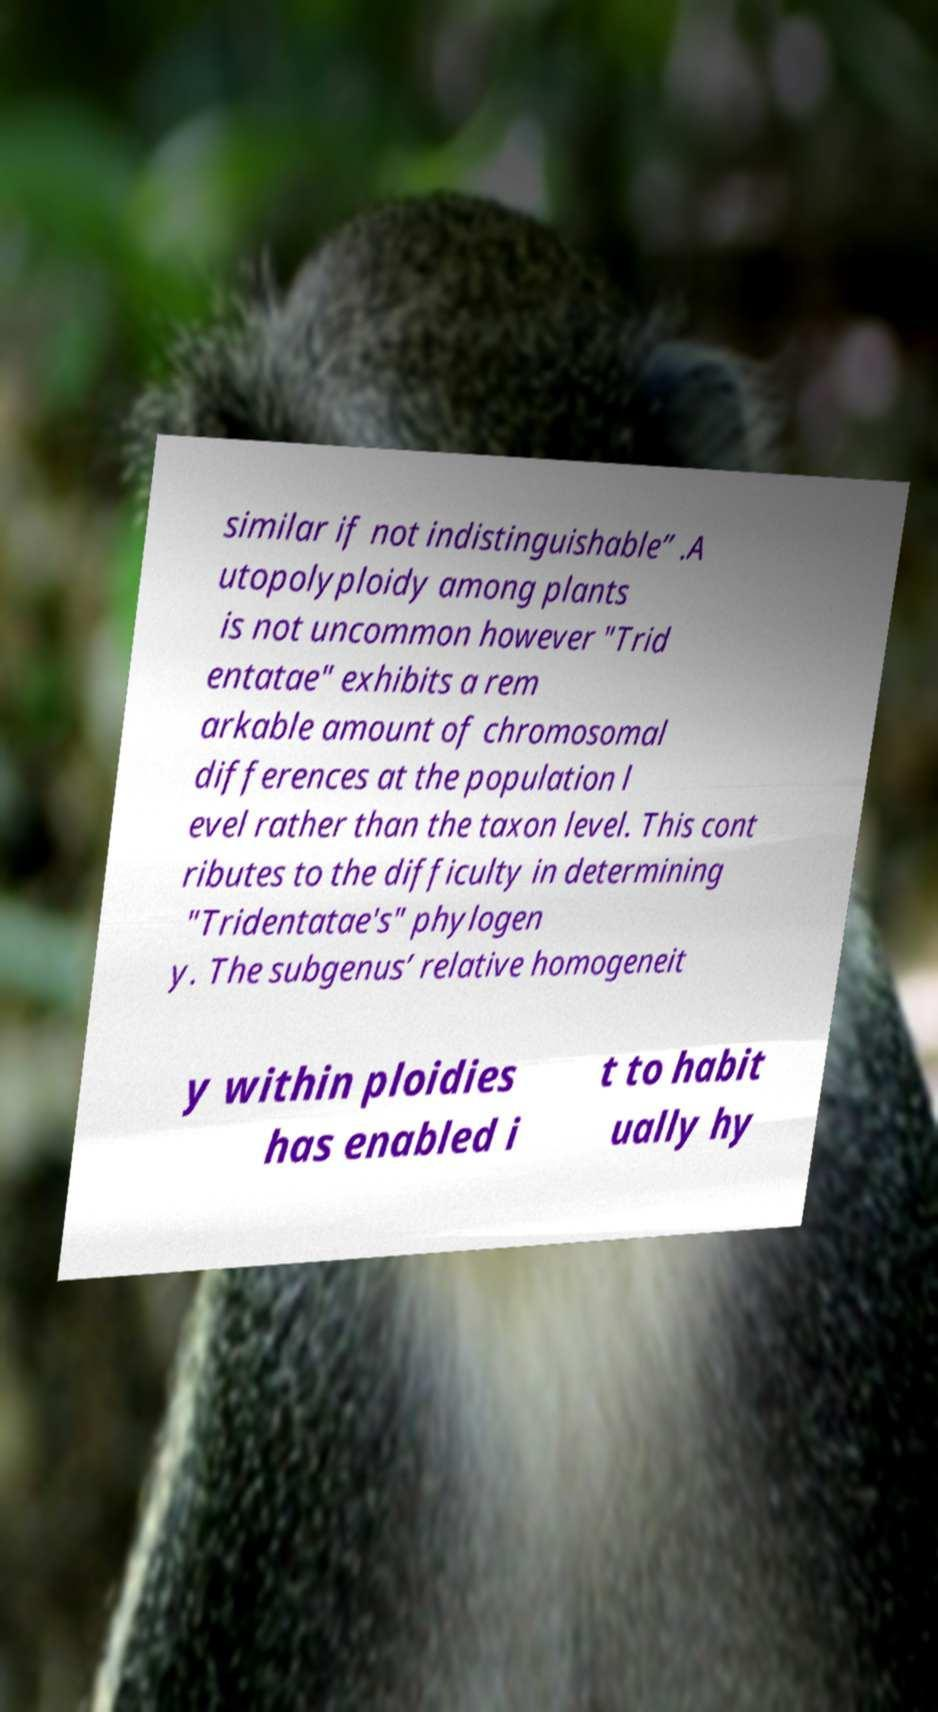Could you extract and type out the text from this image? similar if not indistinguishable” .A utopolyploidy among plants is not uncommon however "Trid entatae" exhibits a rem arkable amount of chromosomal differences at the population l evel rather than the taxon level. This cont ributes to the difficulty in determining "Tridentatae's" phylogen y. The subgenus’ relative homogeneit y within ploidies has enabled i t to habit ually hy 